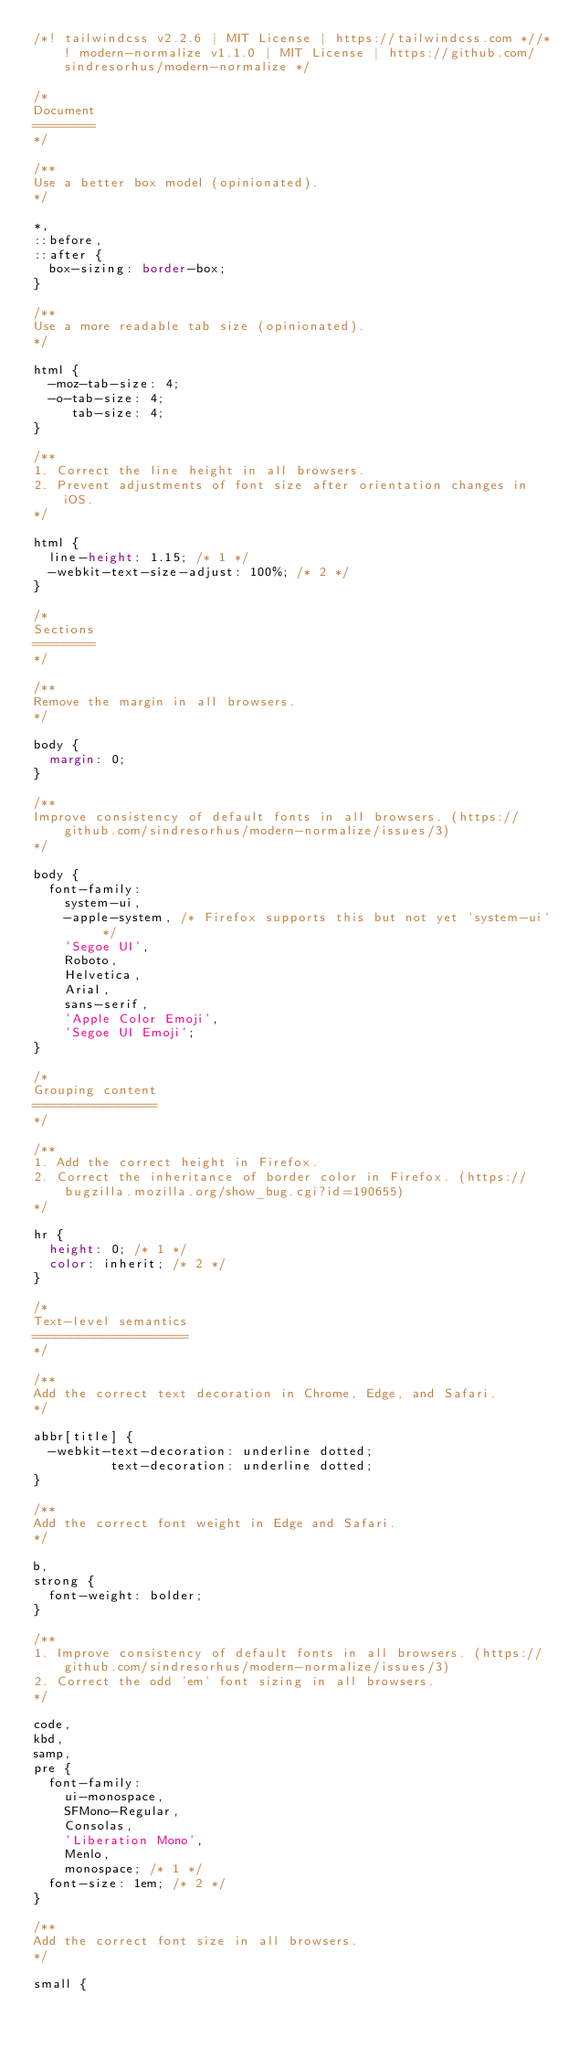Convert code to text. <code><loc_0><loc_0><loc_500><loc_500><_CSS_>/*! tailwindcss v2.2.6 | MIT License | https://tailwindcss.com *//*! modern-normalize v1.1.0 | MIT License | https://github.com/sindresorhus/modern-normalize */

/*
Document
========
*/

/**
Use a better box model (opinionated).
*/

*,
::before,
::after {
	box-sizing: border-box;
}

/**
Use a more readable tab size (opinionated).
*/

html {
	-moz-tab-size: 4;
	-o-tab-size: 4;
	   tab-size: 4;
}

/**
1. Correct the line height in all browsers.
2. Prevent adjustments of font size after orientation changes in iOS.
*/

html {
	line-height: 1.15; /* 1 */
	-webkit-text-size-adjust: 100%; /* 2 */
}

/*
Sections
========
*/

/**
Remove the margin in all browsers.
*/

body {
	margin: 0;
}

/**
Improve consistency of default fonts in all browsers. (https://github.com/sindresorhus/modern-normalize/issues/3)
*/

body {
	font-family:
		system-ui,
		-apple-system, /* Firefox supports this but not yet `system-ui` */
		'Segoe UI',
		Roboto,
		Helvetica,
		Arial,
		sans-serif,
		'Apple Color Emoji',
		'Segoe UI Emoji';
}

/*
Grouping content
================
*/

/**
1. Add the correct height in Firefox.
2. Correct the inheritance of border color in Firefox. (https://bugzilla.mozilla.org/show_bug.cgi?id=190655)
*/

hr {
	height: 0; /* 1 */
	color: inherit; /* 2 */
}

/*
Text-level semantics
====================
*/

/**
Add the correct text decoration in Chrome, Edge, and Safari.
*/

abbr[title] {
	-webkit-text-decoration: underline dotted;
	        text-decoration: underline dotted;
}

/**
Add the correct font weight in Edge and Safari.
*/

b,
strong {
	font-weight: bolder;
}

/**
1. Improve consistency of default fonts in all browsers. (https://github.com/sindresorhus/modern-normalize/issues/3)
2. Correct the odd 'em' font sizing in all browsers.
*/

code,
kbd,
samp,
pre {
	font-family:
		ui-monospace,
		SFMono-Regular,
		Consolas,
		'Liberation Mono',
		Menlo,
		monospace; /* 1 */
	font-size: 1em; /* 2 */
}

/**
Add the correct font size in all browsers.
*/

small {</code> 